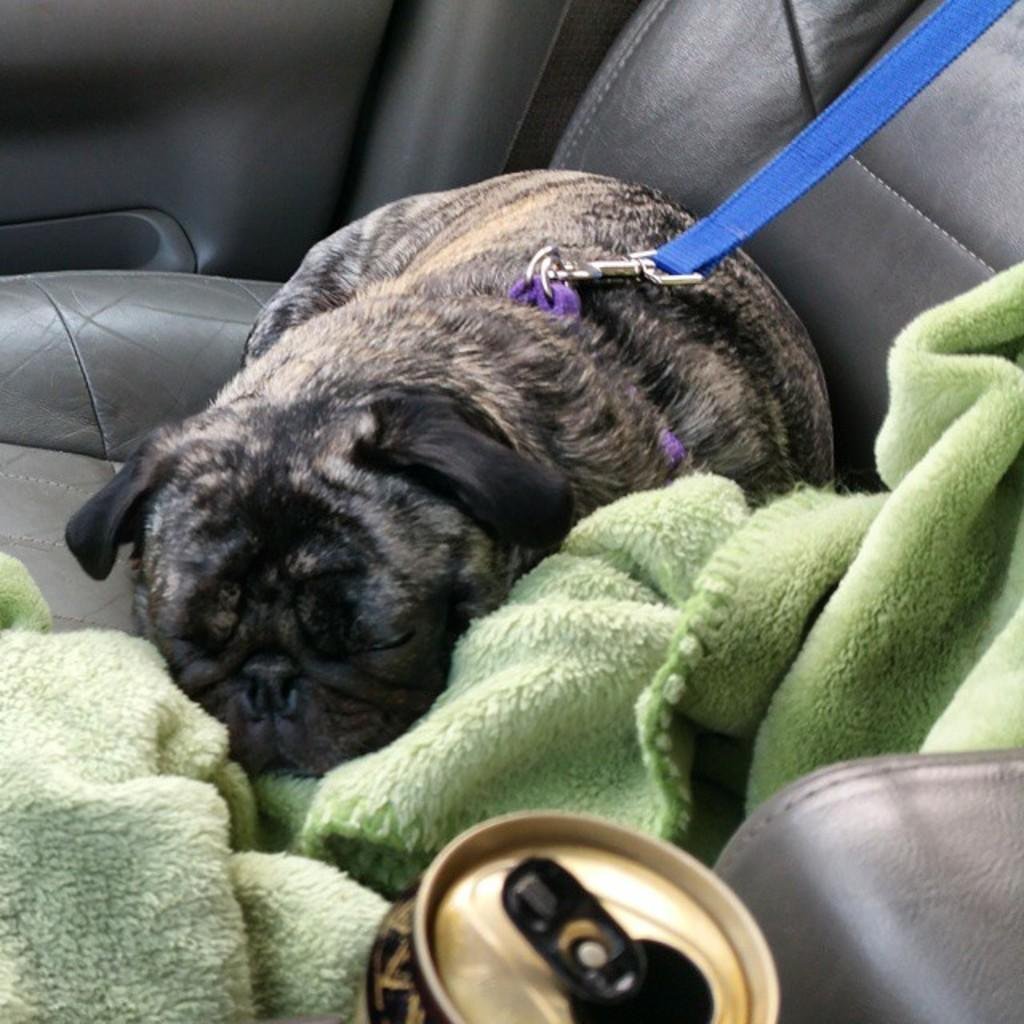What is the setting of the image? The image shows the inside view of a car. What can be seen inside the car? There is a dog in the car, and it is tied with a leash. What is the dog doing in the image? The dog is sleeping. Are there any other objects in the car? Yes, there is a cloth and a bottle in the car. What type of food is the dog eating in the image? There is no food visible in the image; the dog is sleeping and not eating. Can you tell me how many candles are on the birthday cake in the image? There is no birthday cake present in the image; it features the inside view of a car with a sleeping dog. 